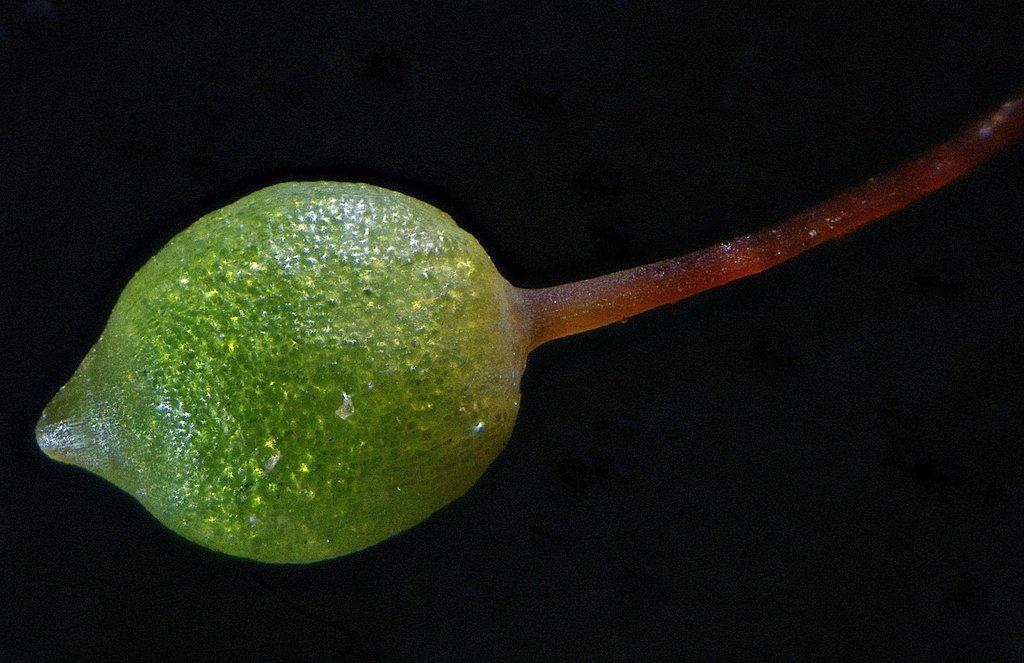What is present in the image? There is a plant in the image. What can be said about the color of the plant? The plant is green in color. How many friends are visible with the plant in the image? There are no friends visible with the plant in the image, as the facts only mention the presence of a plant. 